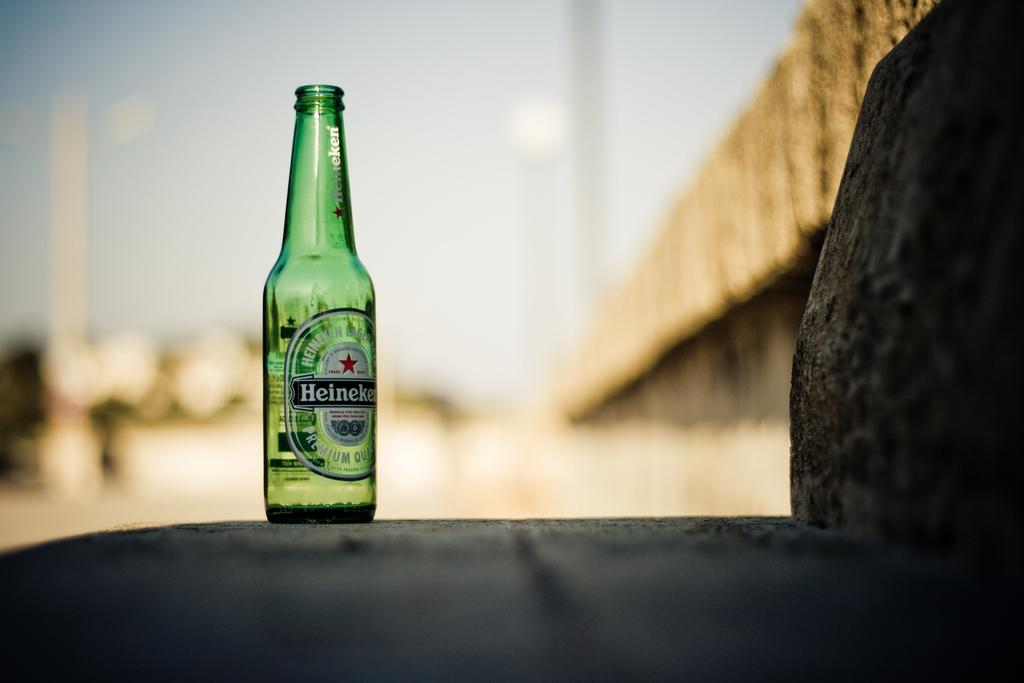<image>
Give a short and clear explanation of the subsequent image. An empty bottle of Heineken sits outside in the shadows. 